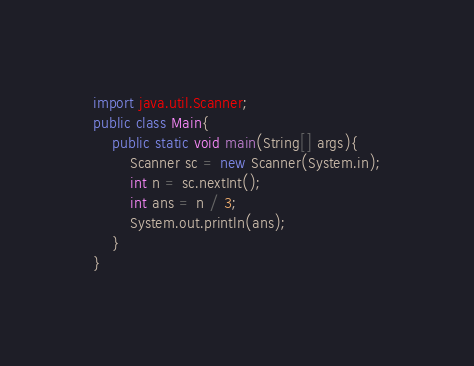Convert code to text. <code><loc_0><loc_0><loc_500><loc_500><_Java_>import java.util.Scanner;
public class Main{
    public static void main(String[] args){
        Scanner sc = new Scanner(System.in);
        int n = sc.nextInt();
        int ans = n / 3;
        System.out.println(ans);
    }
}
</code> 